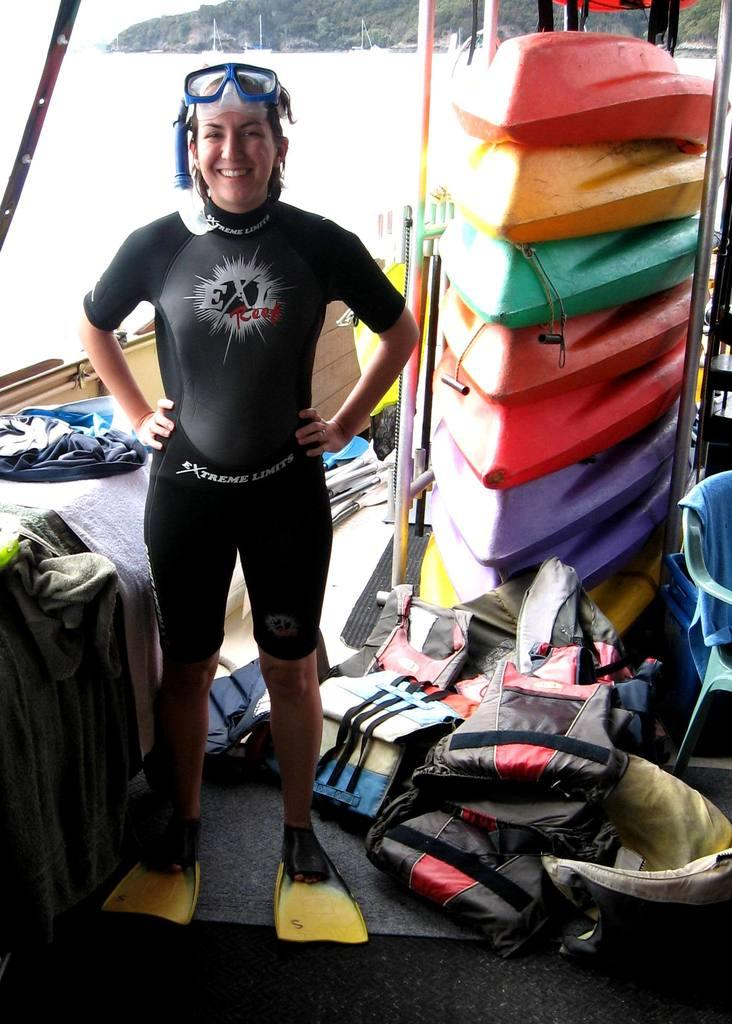<image>
Share a concise interpretation of the image provided. A girl preparing to scuba dive with an Extreme Limits wet suit on. 